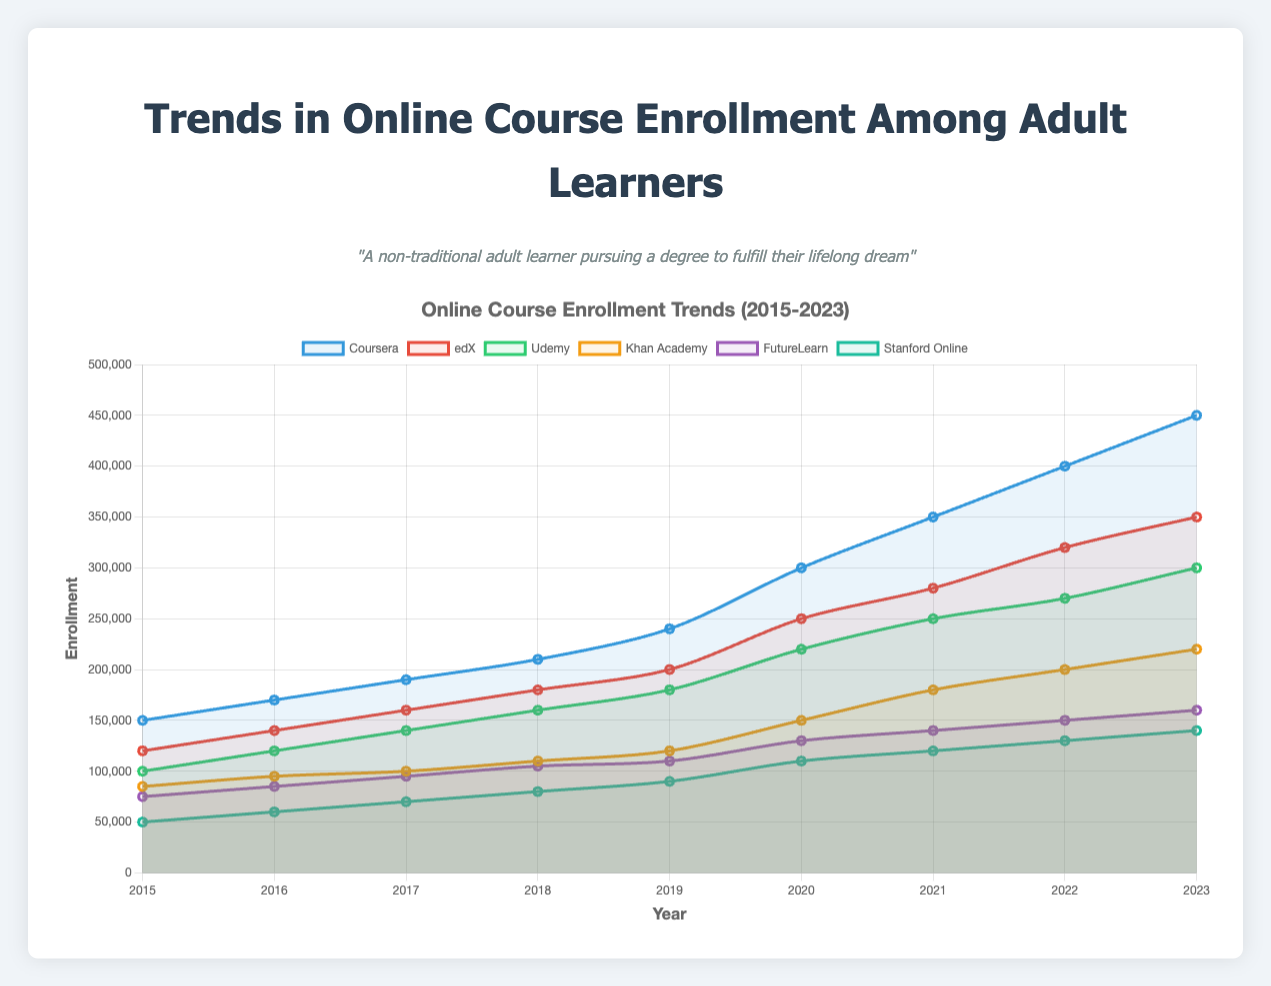What is the overall trend in enrollment for Coursera from 2015 to 2023? Observing the line representing Coursera on the plot, it consistently rises from 150,000 in 2015 to 450,000 in 2023, indicating a steady increase in enrollment.
Answer: Steady increase Which platform had the highest number of enrollments in 2023? Looking at the highest point on the plot for 2023, the Coursera line reaches 450,000, which is higher than any other platform for that year.
Answer: Coursera How does the enrollment for FutureLearn in 2023 compare to edX in 2016? The enrollment for FutureLearn in 2023 is 160,000, whereas edX had 140,000 in 2016. FutureLearn in 2023 is higher by comparing these points on the plot.
Answer: FutureLearn in 2023 is higher What is the average enrollment for Stanford Online from 2015 to 2023? To find the average, sum the enrollments between 2015 and 2023 (50,000 + 60,000 + 70,000 + 80,000 + 90,000 + 110,000 + 120,000 + 130,000 + 140,000) = 850,000, then divide by the number of years (9). The average enrollment is 850,000 / 9 ≈ 94,444.
Answer: ≈ 94,444 Which platform shows the most growth between 2015 and 2023? Calculate the difference between 2023 and 2015 enrollments for each platform. The differences are: Coursera (450,000 - 150,000 = 300,000), edX (350,000 - 120,000 = 230,000), Udemy (300,000 - 100,000 = 200,000), Khan Academy (220,000 - 85,000 = 135,000), FutureLearn (160,000 - 75,000 = 85,000), Stanford Online (140,000 - 50,000 = 90,000). Coursera shows the highest growth of 300,000.
Answer: Coursera How did the enrollment trends for Khan Academy change from 2020 to 2023? In 2020, Khan Academy had 150,000 enrollments, which increased to 220,000 in 2023. This shows an upward trend of 70,000 enrollments over the period.
Answer: Increased by 70,000 Is the enrollment for Udemy in 2023 more than double its enrollment in 2016? Udemy had 120,000 enrollments in 2016, and in 2023 it had 300,000. Doubling 120,000 gives 240,000. Since 300,000 is more than 240,000, the enrollment in 2023 is more than double the 2016 enrollment.
Answer: Yes What is the ratio of Coursera to Khan Academy enrollments in 2021? In 2021, Coursera had 350,000 enrollments, and Khan Academy had 180,000 enrollments. The ratio is 350,000 / 180,000 = 1.94.
Answer: 1.94 Which two platforms are closest in enrollment in 2022? In 2022, the enrollments are: Coursera (400,000), edX (320,000), Udemy (270,000), Khan Academy (200,000), FutureLearn (150,000), and Stanford Online (130,000). FutureLearn (150,000) and Stanford Online (130,000) have the closest enrollments.
Answer: FutureLearn and Stanford Online What is the combined enrollment of Udemy and Stanford Online in 2020? In 2020, Udemy had 220,000 and Stanford Online had 110,000 enrollments. The combined enrollment is 220,000 + 110,000 = 330,000.
Answer: 330,000 